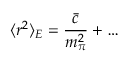<formula> <loc_0><loc_0><loc_500><loc_500>\langle r ^ { 2 } \rangle _ { E } = \frac { \bar { c } } { m _ { \pi } ^ { 2 } } + \dots</formula> 